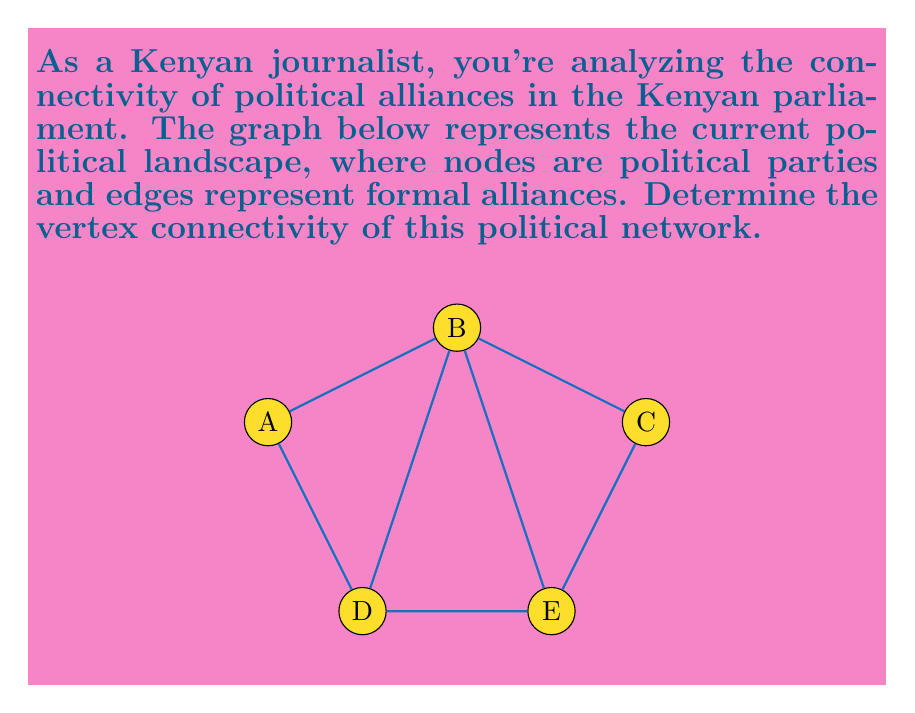Could you help me with this problem? To determine the vertex connectivity of this political network, we need to follow these steps:

1) Vertex connectivity is defined as the minimum number of vertices that need to be removed to disconnect the graph.

2) We need to check how many vertices need to be removed to isolate a vertex or split the graph into two or more components.

3) Let's analyze each possibility:

   a) Removing vertex A: The graph remains connected.
   b) Removing vertex B: The graph remains connected.
   c) Removing vertex C: The graph remains connected.
   d) Removing vertex D: The graph remains connected.
   e) Removing vertex E: The graph remains connected.

4) We see that removing any single vertex does not disconnect the graph.

5) Now, let's try removing two vertices:

   a) Removing vertices A and C: This disconnects the graph into two components {B} and {D,E}.

6) We found that removing two vertices can disconnect the graph, and we cannot disconnect it by removing only one vertex.

Therefore, the vertex connectivity of this political network is 2.

This means that the political alliance structure is relatively robust, requiring the removal of at least two parties to break the network of alliances completely.
Answer: 2 